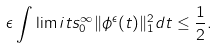<formula> <loc_0><loc_0><loc_500><loc_500>\epsilon \int \lim i t s _ { 0 } ^ { \infty } \| \phi ^ { \epsilon } ( t ) \| _ { 1 } ^ { 2 } d t \leq \frac { 1 } { 2 } .</formula> 